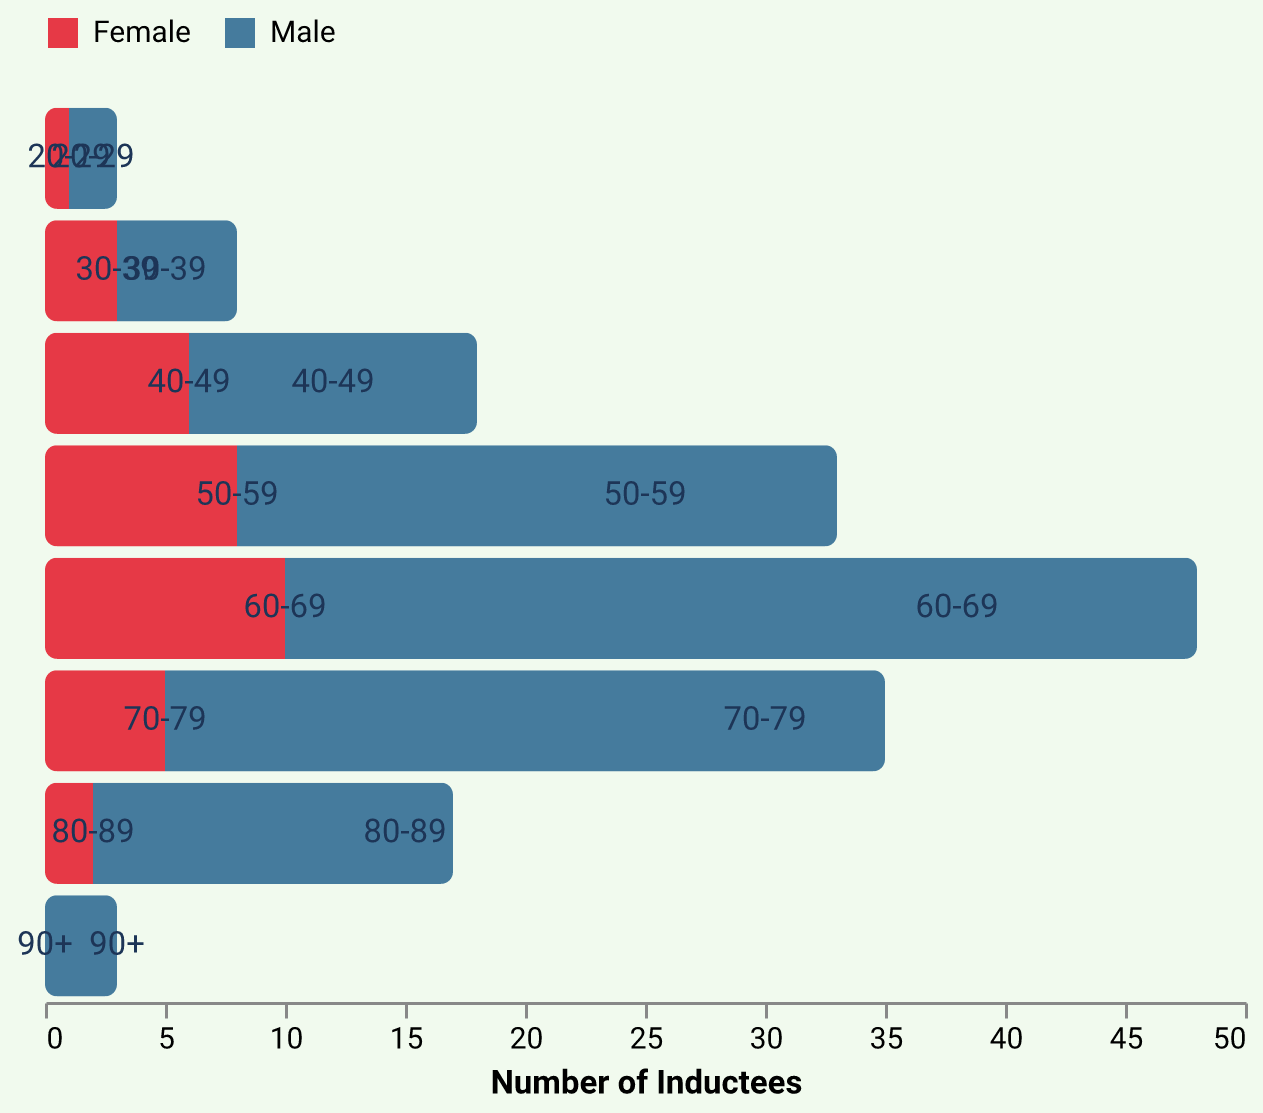What age group has the highest number of male inductees? The age group with the highest number of male inductees can be determined by looking at the bars on the male side of the population pyramid. The largest bar corresponds to the 60-69 age group.
Answer: 60-69 How many female inductees are there in the 50-59 age group? To find the number of female inductees in the 50-59 age group, observe the bar for females corresponding to this age group. The value is represented by -8.
Answer: 8 Which gender has more inductees in the 70-79 age group? Compare the lengths of the bars for males and females in the 70-79 age group. The male bar extends to 30, while the female bar extends to -5. Hence, males have more inductees.
Answer: Male What is the total count of inductees for the 40-49 age group? To find the total count, add the absolute values of the male and female counts for the 40-49 age group. The male count is 12, and the female count is 6. Total = 12 + 6.
Answer: 18 What is the percentage of female inductees in the 60-69 age group in comparison to the total inductees for the same age group? First, determine the total number of inductees in the 60-69 age group by adding the absolute values: 38 (male) + 10 (female) = 48. Then, calculate the percentage of female inductees: (10 / 48) * 100 ≈ 20.83%.
Answer: ~20.83% Which age group has the least number of total inductees? To identify this, sum the number of inductees (absolute values) for each age group and find the group with the smallest sum. The counts are:
- 20-29: 3
- 30-39: 8
- 40-49: 18
- 50-59: 33
- 60-69: 48
- 70-79: 35
- 80-89: 17
- 90+: 3
Thus, 20-29 and 90+ have the least number of total inductees.
Answer: 20-29 and 90+ How does the number of male inductees in the 80-89 age group compare to the number of female inductees in the same age group? To compare, look at the values for males and females in the 80-89 age group. Males have 15 inductees, and females have 2 inductees. Males have more inductees than females.
Answer: Males have more What age group has the ratio of male to female inductees closest to 2:1? Calculate the ratio of male to female inductees for each age group:
- 20-29: 2:1 (exact)
- 30-39: 5:3 ≈ 1.67:1
- 40-49: 12:6 = 2:1 (exact)
- 50-59: 25:8 ≈ 3.125:1
- 60-69: 38:10 ≈ 3.8:1
- 70-79: 30:5 = 6:1
- 80-89: 15:2 = 7.5:1
- 90+: 3:0 (undefined, zero females)
Both 20-29 and 40-49 age groups have the exact 2:1 ratio.
Answer: 20-29 and 40-49 What is the median age group for male inductees? To find the median age group for male inductees, arrange the male counts and find the middle value(s): 2, 5, 12, 25, 30, 38. The middle values are 25 and 30, both fall in the 50-59 and 60-69 age groups with 55 as a perceived midpoint.
Answer: 55 In which age groups are the number of female inductees higher than 3? Identify age groups where the absolute values of the female inductees are greater than 3. The age groups are 40-49, 50-59, and 60-69.
Answer: 40-49, 50-59, 60-69 